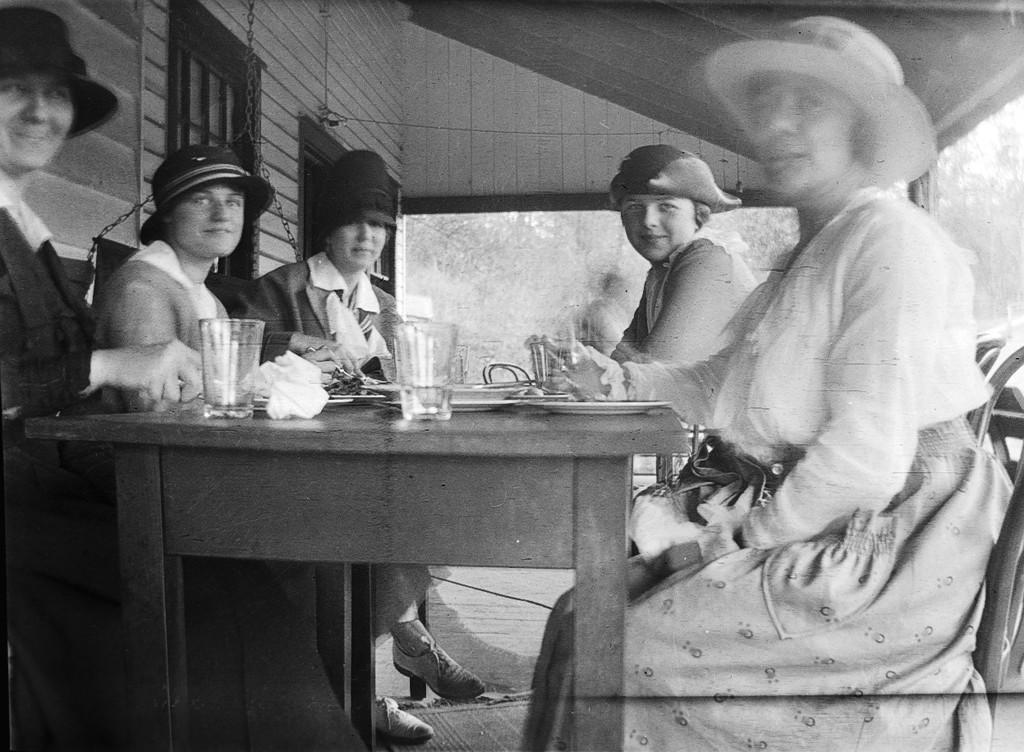What type of location is depicted in the image? The image shows an inside view of a building. What are the people in the image doing? The people are sitting around a table. What objects can be seen on the table? There are glasses on the table. What can be seen in the background of the image? There are trees visible in the background of the image. What type of care is being provided to the trees in the image? There is no indication in the image that any care is being provided to the trees; they are simply visible in the background. 